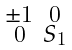Convert formula to latex. <formula><loc_0><loc_0><loc_500><loc_500>\begin{smallmatrix} \pm 1 & 0 \\ 0 & S _ { 1 } \end{smallmatrix}</formula> 